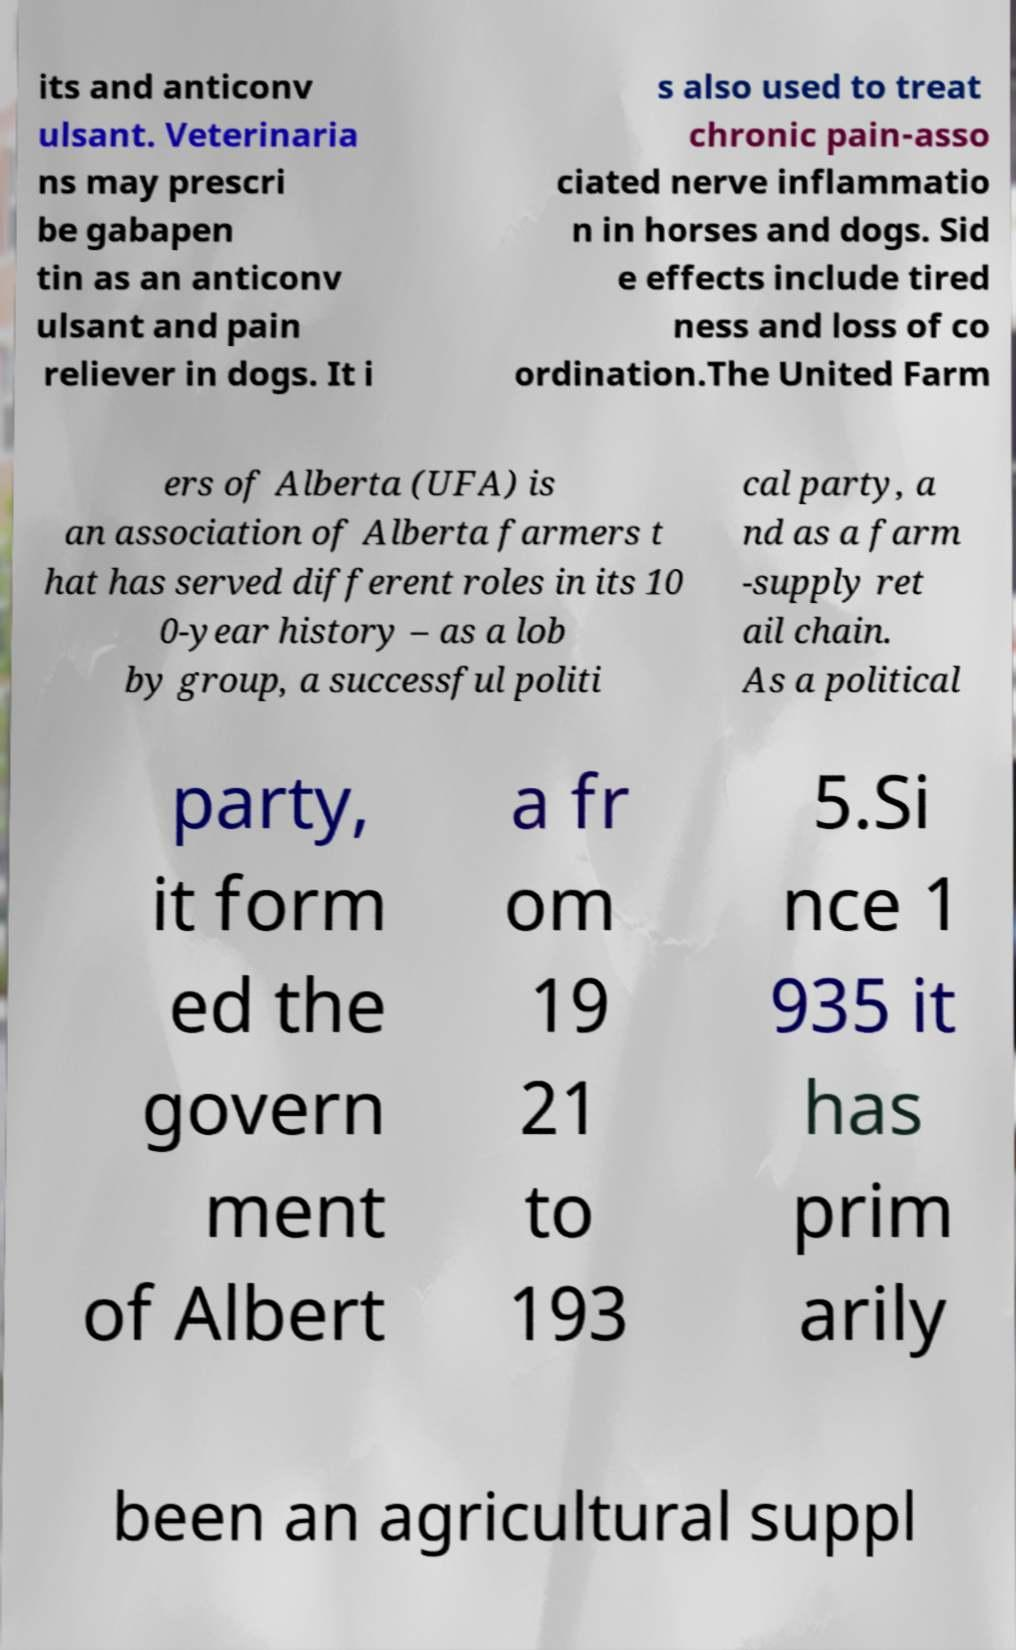Can you read and provide the text displayed in the image?This photo seems to have some interesting text. Can you extract and type it out for me? its and anticonv ulsant. Veterinaria ns may prescri be gabapen tin as an anticonv ulsant and pain reliever in dogs. It i s also used to treat chronic pain-asso ciated nerve inflammatio n in horses and dogs. Sid e effects include tired ness and loss of co ordination.The United Farm ers of Alberta (UFA) is an association of Alberta farmers t hat has served different roles in its 10 0-year history – as a lob by group, a successful politi cal party, a nd as a farm -supply ret ail chain. As a political party, it form ed the govern ment of Albert a fr om 19 21 to 193 5.Si nce 1 935 it has prim arily been an agricultural suppl 